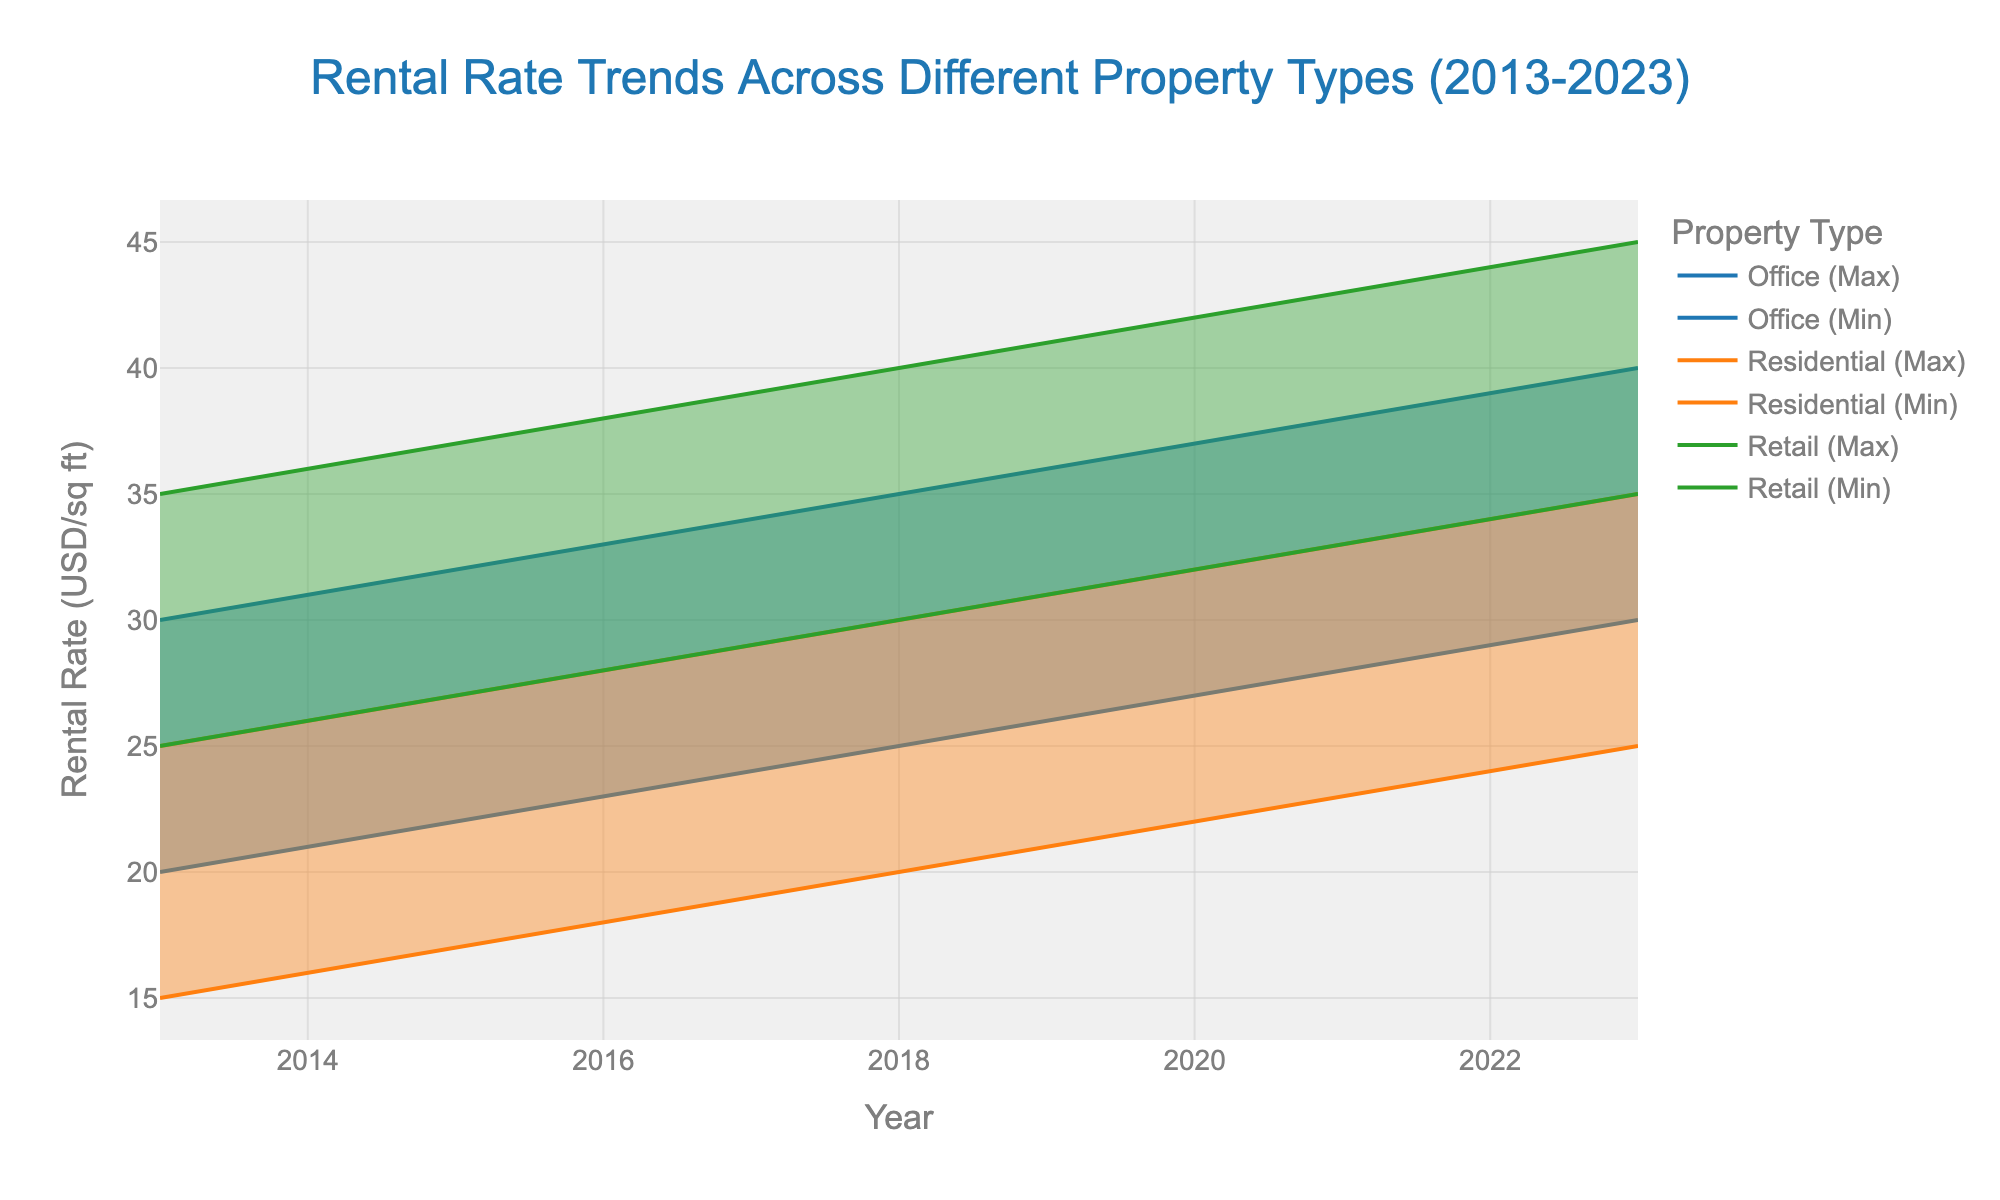What is the title of the chart? The title is displayed at the top center of the chart. It reads "Rental Rate Trends Across Different Property Types (2013-2023)".
Answer: Rental Rate Trends Across Different Property Types (2013-2023) Which property type has the highest max rental rate in 2023? In 2023, the max rental rate for each property type can be seen at the end of their respective lines. The highest max rental rate is for Retail, which is 45 USD/sq ft.
Answer: Retail How much did the max rental rate for Residential properties increase from 2013 to 2023? In 2013, the max rental rate for Residential was 25 USD/sq ft, and in 2023, it was 35 USD/sq ft. The increase is calculated as 35 - 25.
Answer: 10 USD/sq ft Between which years did the Retail property max and min rental rates show the fastest increase? By observing the steepness of the Retail property rental rate lines, the fastest increase can be seen between 2017 and 2018 for both max and min rates.
Answer: 2017-2018 What was the rental rate range for Office properties in 2019? The rental rate range is described by the min and max rates. For Office properties in 2019, the min rate was 26 USD/sq ft and the max rate was 36 USD/sq ft.
Answer: 26-36 USD/sq ft In which year did Office properties have the smallest rental rate range? To find the smallest range, observe the vertical distance between the max and min lines for Office properties over the years. It is smallest in 2013, where the range is 10 USD/sq ft (20 to 30).
Answer: 2013 Which property type had the least variation in its min rental rate across the years shown? By comparing the min rental rate lines for all property types, Residential properties have the least vertical fluctuations, indicating the least variation.
Answer: Residential Which year experienced the same max rental rate for both Office and Residential properties? In 2023, both Office and Residential properties had the same max rental rate, which was 40 USD/sq ft.
Answer: 2023 How many property types are represented in the chart? The chart has three distinct property types shown in different colors: Office, Residential, and Retail.
Answer: 3 Which property type shows a consistent annual increase in both min and max rental rates throughout the decade? By looking at the trends for both min and max rental rates, Retail properties show a consistent annual increase without any declines.
Answer: Retail 